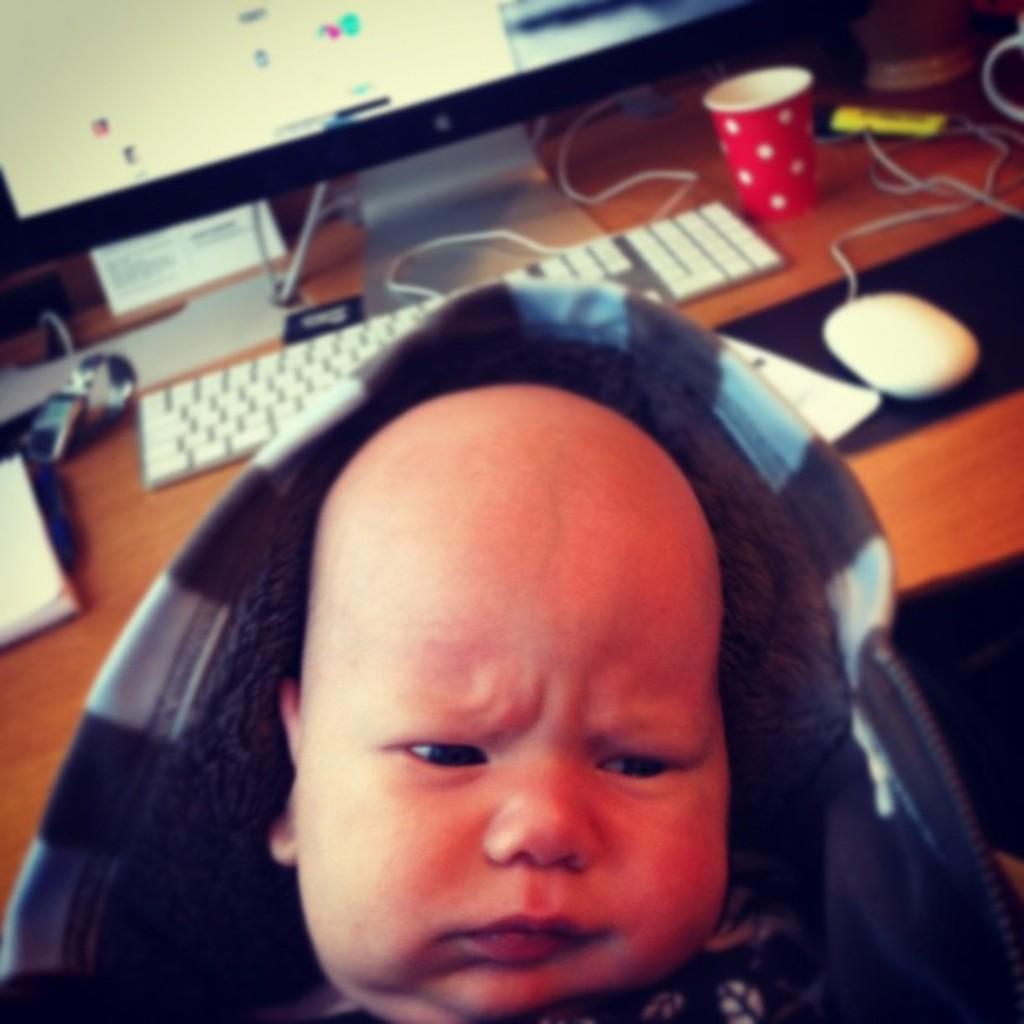How would you summarize this image in a sentence or two? In this picture there is a boy who is wearing hoodie. On the table we can see computer screen, keyboard, mouse, glass, wire, book, paper and other objects. 